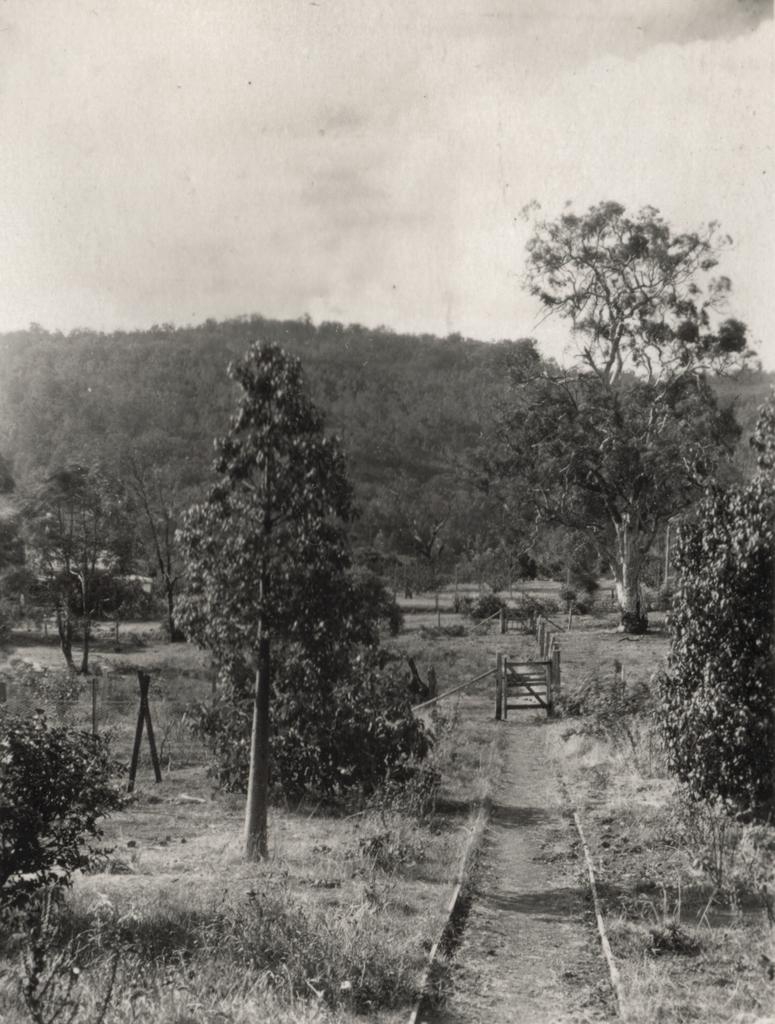What is the color scheme of the image? The image is black and white. What type of vegetation can be seen in the image? There is grass and trees in the image. What structures are present in the image? There are wooden gates in the image. What can be seen in the background of the image? There are hills and the sky visible in the background of the image. How many flowers are present on the arm of the person in the image? There is no person present in the image, and therefore no arm or flowers can be observed. 